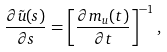Convert formula to latex. <formula><loc_0><loc_0><loc_500><loc_500>\frac { \partial \tilde { u } ( s ) } { \partial s } = \left [ \frac { \partial m _ { u } ( t ) } { \partial t } \right ] ^ { - 1 } ,</formula> 